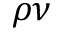<formula> <loc_0><loc_0><loc_500><loc_500>\rho \nu</formula> 